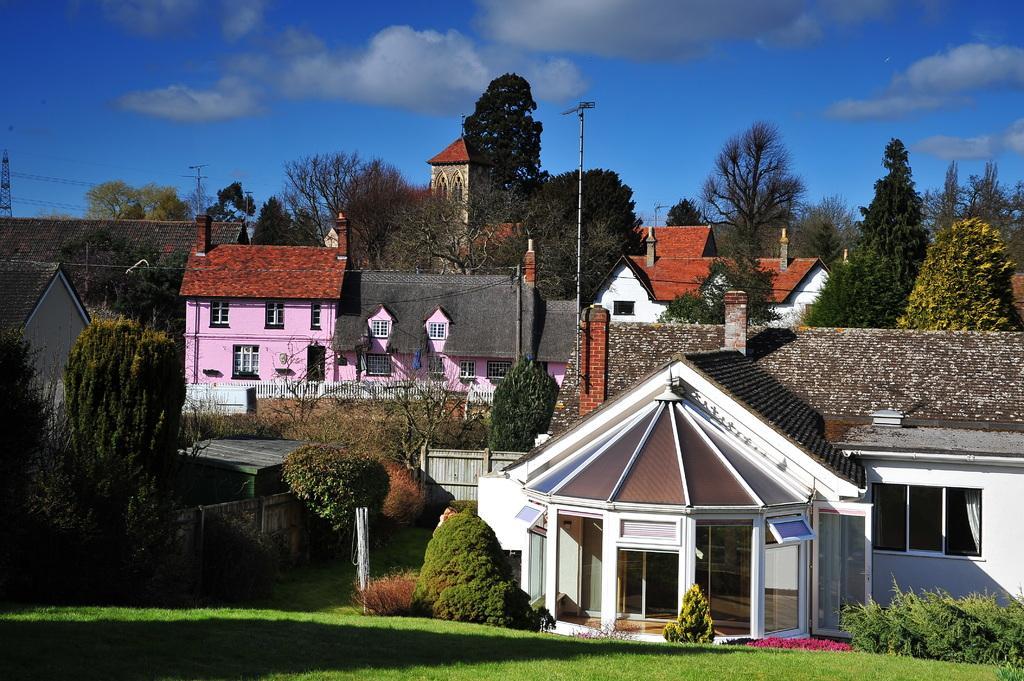Describe this image in one or two sentences. In this image I can see the ground, some grass on the ground, few trees which are green in color, few poles and few buildings. In the background I can see the sky. 